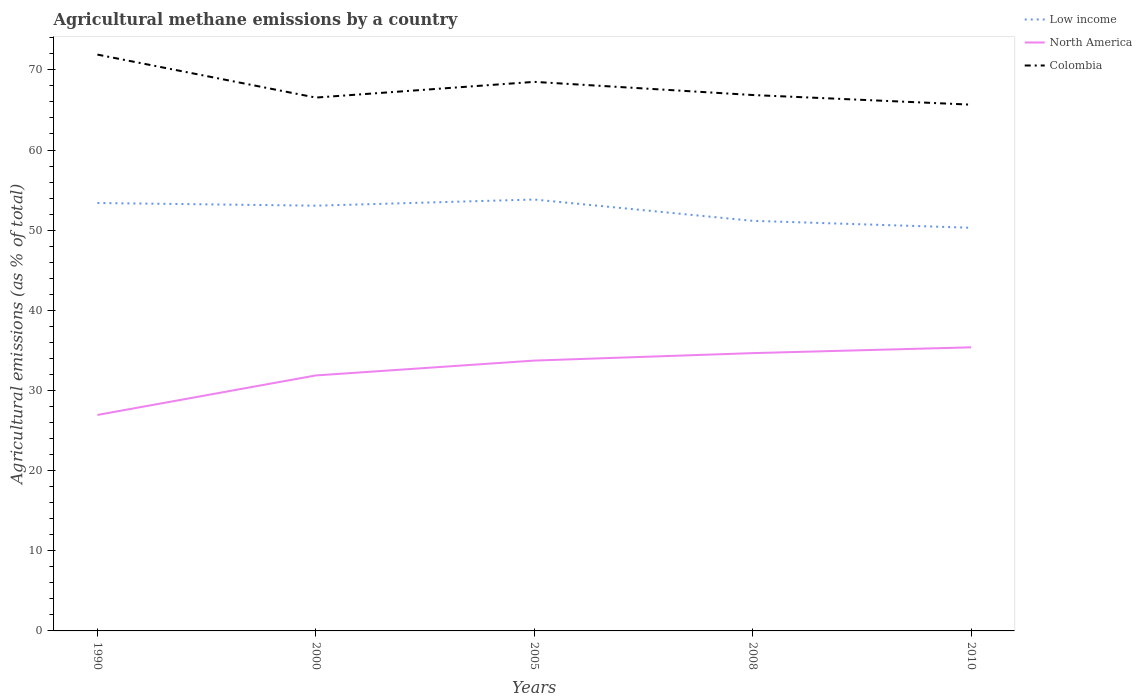How many different coloured lines are there?
Offer a very short reply. 3. Does the line corresponding to North America intersect with the line corresponding to Colombia?
Provide a succinct answer. No. Is the number of lines equal to the number of legend labels?
Provide a succinct answer. Yes. Across all years, what is the maximum amount of agricultural methane emitted in Colombia?
Offer a very short reply. 65.66. In which year was the amount of agricultural methane emitted in North America maximum?
Provide a succinct answer. 1990. What is the total amount of agricultural methane emitted in Low income in the graph?
Ensure brevity in your answer.  2.66. What is the difference between the highest and the second highest amount of agricultural methane emitted in Colombia?
Keep it short and to the point. 6.25. What is the difference between the highest and the lowest amount of agricultural methane emitted in Colombia?
Ensure brevity in your answer.  2. How many lines are there?
Ensure brevity in your answer.  3. What is the difference between two consecutive major ticks on the Y-axis?
Keep it short and to the point. 10. Does the graph contain any zero values?
Your answer should be compact. No. Does the graph contain grids?
Give a very brief answer. No. Where does the legend appear in the graph?
Make the answer very short. Top right. What is the title of the graph?
Make the answer very short. Agricultural methane emissions by a country. What is the label or title of the Y-axis?
Your answer should be very brief. Agricultural emissions (as % of total). What is the Agricultural emissions (as % of total) in Low income in 1990?
Offer a very short reply. 53.39. What is the Agricultural emissions (as % of total) in North America in 1990?
Offer a terse response. 26.95. What is the Agricultural emissions (as % of total) of Colombia in 1990?
Make the answer very short. 71.91. What is the Agricultural emissions (as % of total) of Low income in 2000?
Your answer should be very brief. 53.05. What is the Agricultural emissions (as % of total) in North America in 2000?
Keep it short and to the point. 31.88. What is the Agricultural emissions (as % of total) in Colombia in 2000?
Offer a very short reply. 66.54. What is the Agricultural emissions (as % of total) of Low income in 2005?
Keep it short and to the point. 53.82. What is the Agricultural emissions (as % of total) in North America in 2005?
Offer a very short reply. 33.73. What is the Agricultural emissions (as % of total) in Colombia in 2005?
Give a very brief answer. 68.5. What is the Agricultural emissions (as % of total) of Low income in 2008?
Ensure brevity in your answer.  51.17. What is the Agricultural emissions (as % of total) in North America in 2008?
Offer a very short reply. 34.66. What is the Agricultural emissions (as % of total) of Colombia in 2008?
Provide a succinct answer. 66.86. What is the Agricultural emissions (as % of total) in Low income in 2010?
Give a very brief answer. 50.3. What is the Agricultural emissions (as % of total) in North America in 2010?
Your response must be concise. 35.38. What is the Agricultural emissions (as % of total) in Colombia in 2010?
Your answer should be very brief. 65.66. Across all years, what is the maximum Agricultural emissions (as % of total) in Low income?
Keep it short and to the point. 53.82. Across all years, what is the maximum Agricultural emissions (as % of total) in North America?
Make the answer very short. 35.38. Across all years, what is the maximum Agricultural emissions (as % of total) of Colombia?
Provide a short and direct response. 71.91. Across all years, what is the minimum Agricultural emissions (as % of total) of Low income?
Provide a succinct answer. 50.3. Across all years, what is the minimum Agricultural emissions (as % of total) in North America?
Make the answer very short. 26.95. Across all years, what is the minimum Agricultural emissions (as % of total) in Colombia?
Your answer should be compact. 65.66. What is the total Agricultural emissions (as % of total) of Low income in the graph?
Provide a short and direct response. 261.73. What is the total Agricultural emissions (as % of total) in North America in the graph?
Your answer should be compact. 162.59. What is the total Agricultural emissions (as % of total) of Colombia in the graph?
Provide a succinct answer. 339.47. What is the difference between the Agricultural emissions (as % of total) in Low income in 1990 and that in 2000?
Make the answer very short. 0.33. What is the difference between the Agricultural emissions (as % of total) in North America in 1990 and that in 2000?
Give a very brief answer. -4.93. What is the difference between the Agricultural emissions (as % of total) in Colombia in 1990 and that in 2000?
Your answer should be compact. 5.36. What is the difference between the Agricultural emissions (as % of total) in Low income in 1990 and that in 2005?
Provide a succinct answer. -0.44. What is the difference between the Agricultural emissions (as % of total) in North America in 1990 and that in 2005?
Give a very brief answer. -6.78. What is the difference between the Agricultural emissions (as % of total) of Colombia in 1990 and that in 2005?
Your answer should be very brief. 3.4. What is the difference between the Agricultural emissions (as % of total) in Low income in 1990 and that in 2008?
Offer a terse response. 2.22. What is the difference between the Agricultural emissions (as % of total) of North America in 1990 and that in 2008?
Provide a short and direct response. -7.71. What is the difference between the Agricultural emissions (as % of total) in Colombia in 1990 and that in 2008?
Provide a succinct answer. 5.04. What is the difference between the Agricultural emissions (as % of total) in Low income in 1990 and that in 2010?
Provide a succinct answer. 3.09. What is the difference between the Agricultural emissions (as % of total) in North America in 1990 and that in 2010?
Provide a short and direct response. -8.44. What is the difference between the Agricultural emissions (as % of total) of Colombia in 1990 and that in 2010?
Keep it short and to the point. 6.25. What is the difference between the Agricultural emissions (as % of total) of Low income in 2000 and that in 2005?
Provide a short and direct response. -0.77. What is the difference between the Agricultural emissions (as % of total) of North America in 2000 and that in 2005?
Offer a terse response. -1.85. What is the difference between the Agricultural emissions (as % of total) in Colombia in 2000 and that in 2005?
Your response must be concise. -1.96. What is the difference between the Agricultural emissions (as % of total) in Low income in 2000 and that in 2008?
Provide a succinct answer. 1.89. What is the difference between the Agricultural emissions (as % of total) in North America in 2000 and that in 2008?
Offer a terse response. -2.78. What is the difference between the Agricultural emissions (as % of total) in Colombia in 2000 and that in 2008?
Your answer should be compact. -0.32. What is the difference between the Agricultural emissions (as % of total) in Low income in 2000 and that in 2010?
Make the answer very short. 2.76. What is the difference between the Agricultural emissions (as % of total) in North America in 2000 and that in 2010?
Give a very brief answer. -3.51. What is the difference between the Agricultural emissions (as % of total) of Colombia in 2000 and that in 2010?
Your answer should be compact. 0.88. What is the difference between the Agricultural emissions (as % of total) in Low income in 2005 and that in 2008?
Provide a succinct answer. 2.66. What is the difference between the Agricultural emissions (as % of total) of North America in 2005 and that in 2008?
Provide a succinct answer. -0.93. What is the difference between the Agricultural emissions (as % of total) in Colombia in 2005 and that in 2008?
Make the answer very short. 1.64. What is the difference between the Agricultural emissions (as % of total) in Low income in 2005 and that in 2010?
Your response must be concise. 3.52. What is the difference between the Agricultural emissions (as % of total) of North America in 2005 and that in 2010?
Your answer should be very brief. -1.65. What is the difference between the Agricultural emissions (as % of total) of Colombia in 2005 and that in 2010?
Ensure brevity in your answer.  2.84. What is the difference between the Agricultural emissions (as % of total) of Low income in 2008 and that in 2010?
Keep it short and to the point. 0.87. What is the difference between the Agricultural emissions (as % of total) of North America in 2008 and that in 2010?
Provide a short and direct response. -0.72. What is the difference between the Agricultural emissions (as % of total) in Colombia in 2008 and that in 2010?
Your answer should be compact. 1.2. What is the difference between the Agricultural emissions (as % of total) in Low income in 1990 and the Agricultural emissions (as % of total) in North America in 2000?
Ensure brevity in your answer.  21.51. What is the difference between the Agricultural emissions (as % of total) in Low income in 1990 and the Agricultural emissions (as % of total) in Colombia in 2000?
Your response must be concise. -13.15. What is the difference between the Agricultural emissions (as % of total) of North America in 1990 and the Agricultural emissions (as % of total) of Colombia in 2000?
Provide a short and direct response. -39.6. What is the difference between the Agricultural emissions (as % of total) of Low income in 1990 and the Agricultural emissions (as % of total) of North America in 2005?
Your answer should be very brief. 19.66. What is the difference between the Agricultural emissions (as % of total) of Low income in 1990 and the Agricultural emissions (as % of total) of Colombia in 2005?
Offer a very short reply. -15.11. What is the difference between the Agricultural emissions (as % of total) of North America in 1990 and the Agricultural emissions (as % of total) of Colombia in 2005?
Offer a terse response. -41.56. What is the difference between the Agricultural emissions (as % of total) of Low income in 1990 and the Agricultural emissions (as % of total) of North America in 2008?
Make the answer very short. 18.73. What is the difference between the Agricultural emissions (as % of total) in Low income in 1990 and the Agricultural emissions (as % of total) in Colombia in 2008?
Ensure brevity in your answer.  -13.47. What is the difference between the Agricultural emissions (as % of total) in North America in 1990 and the Agricultural emissions (as % of total) in Colombia in 2008?
Offer a terse response. -39.92. What is the difference between the Agricultural emissions (as % of total) of Low income in 1990 and the Agricultural emissions (as % of total) of North America in 2010?
Offer a terse response. 18.01. What is the difference between the Agricultural emissions (as % of total) of Low income in 1990 and the Agricultural emissions (as % of total) of Colombia in 2010?
Make the answer very short. -12.27. What is the difference between the Agricultural emissions (as % of total) in North America in 1990 and the Agricultural emissions (as % of total) in Colombia in 2010?
Offer a terse response. -38.71. What is the difference between the Agricultural emissions (as % of total) of Low income in 2000 and the Agricultural emissions (as % of total) of North America in 2005?
Offer a very short reply. 19.33. What is the difference between the Agricultural emissions (as % of total) in Low income in 2000 and the Agricultural emissions (as % of total) in Colombia in 2005?
Your response must be concise. -15.45. What is the difference between the Agricultural emissions (as % of total) of North America in 2000 and the Agricultural emissions (as % of total) of Colombia in 2005?
Keep it short and to the point. -36.63. What is the difference between the Agricultural emissions (as % of total) of Low income in 2000 and the Agricultural emissions (as % of total) of North America in 2008?
Ensure brevity in your answer.  18.4. What is the difference between the Agricultural emissions (as % of total) of Low income in 2000 and the Agricultural emissions (as % of total) of Colombia in 2008?
Keep it short and to the point. -13.81. What is the difference between the Agricultural emissions (as % of total) of North America in 2000 and the Agricultural emissions (as % of total) of Colombia in 2008?
Make the answer very short. -34.99. What is the difference between the Agricultural emissions (as % of total) of Low income in 2000 and the Agricultural emissions (as % of total) of North America in 2010?
Your answer should be very brief. 17.67. What is the difference between the Agricultural emissions (as % of total) of Low income in 2000 and the Agricultural emissions (as % of total) of Colombia in 2010?
Ensure brevity in your answer.  -12.6. What is the difference between the Agricultural emissions (as % of total) in North America in 2000 and the Agricultural emissions (as % of total) in Colombia in 2010?
Offer a very short reply. -33.78. What is the difference between the Agricultural emissions (as % of total) of Low income in 2005 and the Agricultural emissions (as % of total) of North America in 2008?
Make the answer very short. 19.17. What is the difference between the Agricultural emissions (as % of total) in Low income in 2005 and the Agricultural emissions (as % of total) in Colombia in 2008?
Offer a terse response. -13.04. What is the difference between the Agricultural emissions (as % of total) in North America in 2005 and the Agricultural emissions (as % of total) in Colombia in 2008?
Offer a terse response. -33.13. What is the difference between the Agricultural emissions (as % of total) of Low income in 2005 and the Agricultural emissions (as % of total) of North America in 2010?
Your response must be concise. 18.44. What is the difference between the Agricultural emissions (as % of total) in Low income in 2005 and the Agricultural emissions (as % of total) in Colombia in 2010?
Keep it short and to the point. -11.84. What is the difference between the Agricultural emissions (as % of total) in North America in 2005 and the Agricultural emissions (as % of total) in Colombia in 2010?
Offer a terse response. -31.93. What is the difference between the Agricultural emissions (as % of total) of Low income in 2008 and the Agricultural emissions (as % of total) of North America in 2010?
Your answer should be compact. 15.78. What is the difference between the Agricultural emissions (as % of total) in Low income in 2008 and the Agricultural emissions (as % of total) in Colombia in 2010?
Your response must be concise. -14.49. What is the difference between the Agricultural emissions (as % of total) in North America in 2008 and the Agricultural emissions (as % of total) in Colombia in 2010?
Give a very brief answer. -31. What is the average Agricultural emissions (as % of total) of Low income per year?
Your answer should be compact. 52.35. What is the average Agricultural emissions (as % of total) in North America per year?
Provide a succinct answer. 32.52. What is the average Agricultural emissions (as % of total) in Colombia per year?
Your response must be concise. 67.89. In the year 1990, what is the difference between the Agricultural emissions (as % of total) in Low income and Agricultural emissions (as % of total) in North America?
Provide a succinct answer. 26.44. In the year 1990, what is the difference between the Agricultural emissions (as % of total) of Low income and Agricultural emissions (as % of total) of Colombia?
Offer a terse response. -18.52. In the year 1990, what is the difference between the Agricultural emissions (as % of total) in North America and Agricultural emissions (as % of total) in Colombia?
Ensure brevity in your answer.  -44.96. In the year 2000, what is the difference between the Agricultural emissions (as % of total) of Low income and Agricultural emissions (as % of total) of North America?
Your answer should be compact. 21.18. In the year 2000, what is the difference between the Agricultural emissions (as % of total) in Low income and Agricultural emissions (as % of total) in Colombia?
Your answer should be very brief. -13.49. In the year 2000, what is the difference between the Agricultural emissions (as % of total) in North America and Agricultural emissions (as % of total) in Colombia?
Offer a terse response. -34.67. In the year 2005, what is the difference between the Agricultural emissions (as % of total) of Low income and Agricultural emissions (as % of total) of North America?
Ensure brevity in your answer.  20.1. In the year 2005, what is the difference between the Agricultural emissions (as % of total) in Low income and Agricultural emissions (as % of total) in Colombia?
Ensure brevity in your answer.  -14.68. In the year 2005, what is the difference between the Agricultural emissions (as % of total) in North America and Agricultural emissions (as % of total) in Colombia?
Your answer should be very brief. -34.77. In the year 2008, what is the difference between the Agricultural emissions (as % of total) in Low income and Agricultural emissions (as % of total) in North America?
Your answer should be very brief. 16.51. In the year 2008, what is the difference between the Agricultural emissions (as % of total) of Low income and Agricultural emissions (as % of total) of Colombia?
Provide a short and direct response. -15.7. In the year 2008, what is the difference between the Agricultural emissions (as % of total) in North America and Agricultural emissions (as % of total) in Colombia?
Provide a succinct answer. -32.2. In the year 2010, what is the difference between the Agricultural emissions (as % of total) in Low income and Agricultural emissions (as % of total) in North America?
Offer a terse response. 14.92. In the year 2010, what is the difference between the Agricultural emissions (as % of total) of Low income and Agricultural emissions (as % of total) of Colombia?
Offer a terse response. -15.36. In the year 2010, what is the difference between the Agricultural emissions (as % of total) of North America and Agricultural emissions (as % of total) of Colombia?
Offer a very short reply. -30.28. What is the ratio of the Agricultural emissions (as % of total) of Low income in 1990 to that in 2000?
Keep it short and to the point. 1.01. What is the ratio of the Agricultural emissions (as % of total) in North America in 1990 to that in 2000?
Your answer should be compact. 0.85. What is the ratio of the Agricultural emissions (as % of total) in Colombia in 1990 to that in 2000?
Provide a succinct answer. 1.08. What is the ratio of the Agricultural emissions (as % of total) of Low income in 1990 to that in 2005?
Offer a terse response. 0.99. What is the ratio of the Agricultural emissions (as % of total) of North America in 1990 to that in 2005?
Your response must be concise. 0.8. What is the ratio of the Agricultural emissions (as % of total) of Colombia in 1990 to that in 2005?
Your answer should be very brief. 1.05. What is the ratio of the Agricultural emissions (as % of total) of Low income in 1990 to that in 2008?
Provide a short and direct response. 1.04. What is the ratio of the Agricultural emissions (as % of total) of North America in 1990 to that in 2008?
Offer a terse response. 0.78. What is the ratio of the Agricultural emissions (as % of total) in Colombia in 1990 to that in 2008?
Your answer should be compact. 1.08. What is the ratio of the Agricultural emissions (as % of total) in Low income in 1990 to that in 2010?
Offer a very short reply. 1.06. What is the ratio of the Agricultural emissions (as % of total) in North America in 1990 to that in 2010?
Your response must be concise. 0.76. What is the ratio of the Agricultural emissions (as % of total) of Colombia in 1990 to that in 2010?
Provide a succinct answer. 1.1. What is the ratio of the Agricultural emissions (as % of total) in Low income in 2000 to that in 2005?
Give a very brief answer. 0.99. What is the ratio of the Agricultural emissions (as % of total) of North America in 2000 to that in 2005?
Offer a very short reply. 0.95. What is the ratio of the Agricultural emissions (as % of total) in Colombia in 2000 to that in 2005?
Your response must be concise. 0.97. What is the ratio of the Agricultural emissions (as % of total) of Low income in 2000 to that in 2008?
Your answer should be compact. 1.04. What is the ratio of the Agricultural emissions (as % of total) of North America in 2000 to that in 2008?
Offer a terse response. 0.92. What is the ratio of the Agricultural emissions (as % of total) of Colombia in 2000 to that in 2008?
Your answer should be very brief. 1. What is the ratio of the Agricultural emissions (as % of total) of Low income in 2000 to that in 2010?
Your response must be concise. 1.05. What is the ratio of the Agricultural emissions (as % of total) of North America in 2000 to that in 2010?
Give a very brief answer. 0.9. What is the ratio of the Agricultural emissions (as % of total) of Colombia in 2000 to that in 2010?
Make the answer very short. 1.01. What is the ratio of the Agricultural emissions (as % of total) in Low income in 2005 to that in 2008?
Your response must be concise. 1.05. What is the ratio of the Agricultural emissions (as % of total) in North America in 2005 to that in 2008?
Give a very brief answer. 0.97. What is the ratio of the Agricultural emissions (as % of total) in Colombia in 2005 to that in 2008?
Provide a succinct answer. 1.02. What is the ratio of the Agricultural emissions (as % of total) in Low income in 2005 to that in 2010?
Make the answer very short. 1.07. What is the ratio of the Agricultural emissions (as % of total) of North America in 2005 to that in 2010?
Provide a succinct answer. 0.95. What is the ratio of the Agricultural emissions (as % of total) of Colombia in 2005 to that in 2010?
Offer a very short reply. 1.04. What is the ratio of the Agricultural emissions (as % of total) in Low income in 2008 to that in 2010?
Ensure brevity in your answer.  1.02. What is the ratio of the Agricultural emissions (as % of total) in North America in 2008 to that in 2010?
Make the answer very short. 0.98. What is the ratio of the Agricultural emissions (as % of total) in Colombia in 2008 to that in 2010?
Provide a succinct answer. 1.02. What is the difference between the highest and the second highest Agricultural emissions (as % of total) in Low income?
Offer a very short reply. 0.44. What is the difference between the highest and the second highest Agricultural emissions (as % of total) in North America?
Make the answer very short. 0.72. What is the difference between the highest and the second highest Agricultural emissions (as % of total) in Colombia?
Provide a succinct answer. 3.4. What is the difference between the highest and the lowest Agricultural emissions (as % of total) of Low income?
Keep it short and to the point. 3.52. What is the difference between the highest and the lowest Agricultural emissions (as % of total) of North America?
Offer a very short reply. 8.44. What is the difference between the highest and the lowest Agricultural emissions (as % of total) in Colombia?
Ensure brevity in your answer.  6.25. 